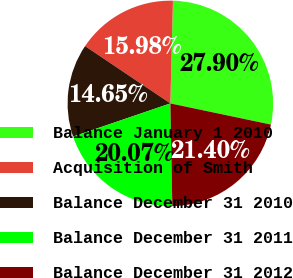Convert chart. <chart><loc_0><loc_0><loc_500><loc_500><pie_chart><fcel>Balance January 1 2010<fcel>Acquisition of Smith<fcel>Balance December 31 2010<fcel>Balance December 31 2011<fcel>Balance December 31 2012<nl><fcel>27.9%<fcel>15.98%<fcel>14.65%<fcel>20.07%<fcel>21.4%<nl></chart> 